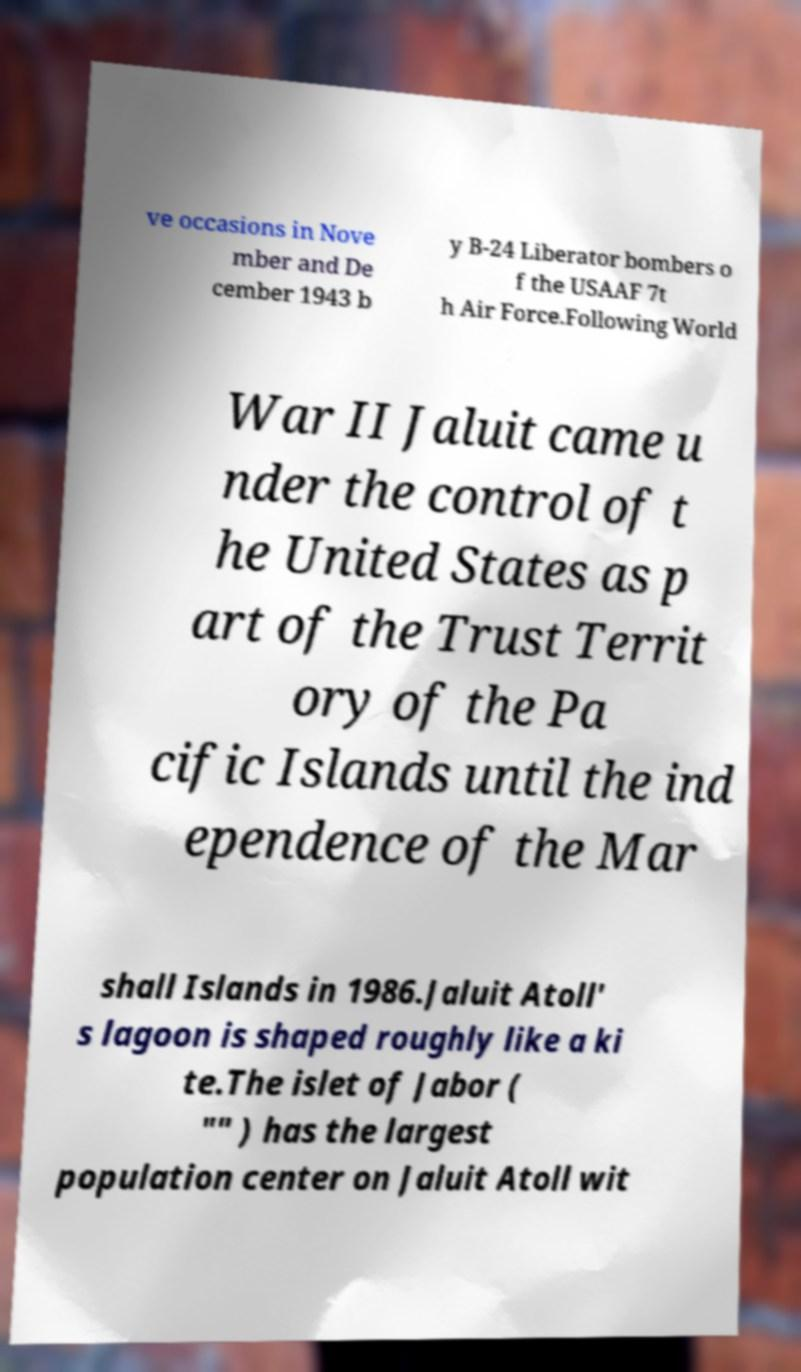I need the written content from this picture converted into text. Can you do that? ve occasions in Nove mber and De cember 1943 b y B-24 Liberator bombers o f the USAAF 7t h Air Force.Following World War II Jaluit came u nder the control of t he United States as p art of the Trust Territ ory of the Pa cific Islands until the ind ependence of the Mar shall Islands in 1986.Jaluit Atoll' s lagoon is shaped roughly like a ki te.The islet of Jabor ( "" ) has the largest population center on Jaluit Atoll wit 